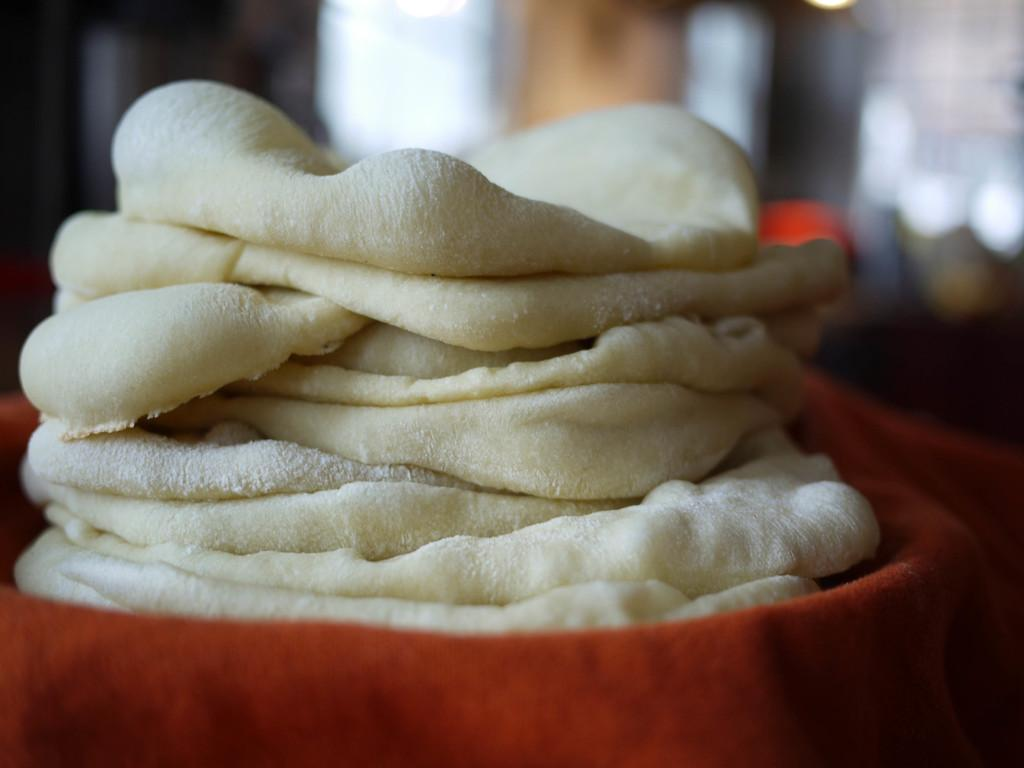What type of objects can be seen in the image? There are food items in the image. How are the food items arranged or placed? The food items are placed on a cloth. Can you describe the background of the image? The background of the image is blurry. What type of beast can be seen hiding in the recess of the image? There is no beast present in the image, and there is no recess in the image either. 